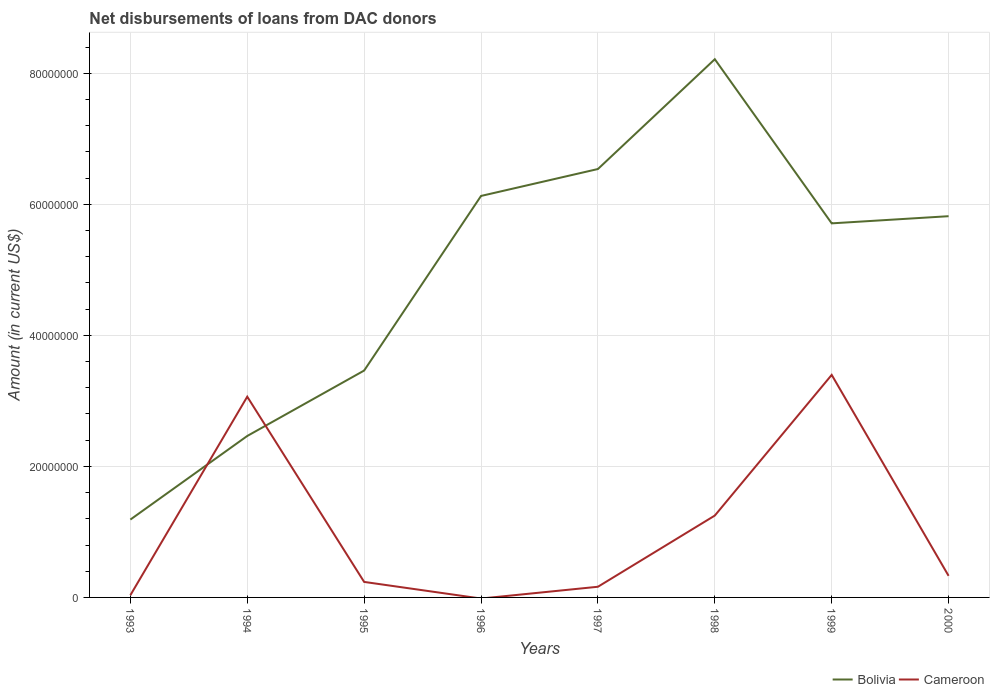How many different coloured lines are there?
Your answer should be compact. 2. Across all years, what is the maximum amount of loans disbursed in Bolivia?
Give a very brief answer. 1.19e+07. What is the total amount of loans disbursed in Bolivia in the graph?
Provide a short and direct response. -4.94e+07. What is the difference between the highest and the second highest amount of loans disbursed in Cameroon?
Provide a short and direct response. 3.40e+07. What is the difference between the highest and the lowest amount of loans disbursed in Cameroon?
Offer a very short reply. 3. Is the amount of loans disbursed in Bolivia strictly greater than the amount of loans disbursed in Cameroon over the years?
Keep it short and to the point. No. Where does the legend appear in the graph?
Ensure brevity in your answer.  Bottom right. What is the title of the graph?
Provide a succinct answer. Net disbursements of loans from DAC donors. Does "Caribbean small states" appear as one of the legend labels in the graph?
Your answer should be very brief. No. What is the label or title of the X-axis?
Make the answer very short. Years. What is the Amount (in current US$) of Bolivia in 1993?
Provide a succinct answer. 1.19e+07. What is the Amount (in current US$) of Cameroon in 1993?
Your response must be concise. 3.40e+05. What is the Amount (in current US$) in Bolivia in 1994?
Provide a succinct answer. 2.46e+07. What is the Amount (in current US$) of Cameroon in 1994?
Provide a succinct answer. 3.06e+07. What is the Amount (in current US$) of Bolivia in 1995?
Ensure brevity in your answer.  3.46e+07. What is the Amount (in current US$) in Cameroon in 1995?
Keep it short and to the point. 2.37e+06. What is the Amount (in current US$) of Bolivia in 1996?
Give a very brief answer. 6.13e+07. What is the Amount (in current US$) in Cameroon in 1996?
Offer a very short reply. 0. What is the Amount (in current US$) in Bolivia in 1997?
Make the answer very short. 6.54e+07. What is the Amount (in current US$) of Cameroon in 1997?
Your answer should be very brief. 1.63e+06. What is the Amount (in current US$) of Bolivia in 1998?
Provide a succinct answer. 8.21e+07. What is the Amount (in current US$) in Cameroon in 1998?
Give a very brief answer. 1.25e+07. What is the Amount (in current US$) of Bolivia in 1999?
Offer a terse response. 5.71e+07. What is the Amount (in current US$) in Cameroon in 1999?
Provide a short and direct response. 3.40e+07. What is the Amount (in current US$) in Bolivia in 2000?
Your answer should be very brief. 5.82e+07. What is the Amount (in current US$) in Cameroon in 2000?
Offer a terse response. 3.30e+06. Across all years, what is the maximum Amount (in current US$) of Bolivia?
Make the answer very short. 8.21e+07. Across all years, what is the maximum Amount (in current US$) of Cameroon?
Keep it short and to the point. 3.40e+07. Across all years, what is the minimum Amount (in current US$) of Bolivia?
Give a very brief answer. 1.19e+07. What is the total Amount (in current US$) in Bolivia in the graph?
Ensure brevity in your answer.  3.95e+08. What is the total Amount (in current US$) of Cameroon in the graph?
Your answer should be very brief. 8.47e+07. What is the difference between the Amount (in current US$) of Bolivia in 1993 and that in 1994?
Ensure brevity in your answer.  -1.28e+07. What is the difference between the Amount (in current US$) in Cameroon in 1993 and that in 1994?
Provide a succinct answer. -3.03e+07. What is the difference between the Amount (in current US$) in Bolivia in 1993 and that in 1995?
Ensure brevity in your answer.  -2.27e+07. What is the difference between the Amount (in current US$) in Cameroon in 1993 and that in 1995?
Ensure brevity in your answer.  -2.03e+06. What is the difference between the Amount (in current US$) of Bolivia in 1993 and that in 1996?
Offer a terse response. -4.94e+07. What is the difference between the Amount (in current US$) of Bolivia in 1993 and that in 1997?
Offer a very short reply. -5.35e+07. What is the difference between the Amount (in current US$) of Cameroon in 1993 and that in 1997?
Give a very brief answer. -1.29e+06. What is the difference between the Amount (in current US$) in Bolivia in 1993 and that in 1998?
Ensure brevity in your answer.  -7.03e+07. What is the difference between the Amount (in current US$) in Cameroon in 1993 and that in 1998?
Ensure brevity in your answer.  -1.22e+07. What is the difference between the Amount (in current US$) in Bolivia in 1993 and that in 1999?
Your answer should be very brief. -4.52e+07. What is the difference between the Amount (in current US$) of Cameroon in 1993 and that in 1999?
Your answer should be compact. -3.36e+07. What is the difference between the Amount (in current US$) in Bolivia in 1993 and that in 2000?
Your response must be concise. -4.63e+07. What is the difference between the Amount (in current US$) in Cameroon in 1993 and that in 2000?
Offer a very short reply. -2.96e+06. What is the difference between the Amount (in current US$) in Bolivia in 1994 and that in 1995?
Provide a short and direct response. -9.98e+06. What is the difference between the Amount (in current US$) of Cameroon in 1994 and that in 1995?
Offer a very short reply. 2.83e+07. What is the difference between the Amount (in current US$) in Bolivia in 1994 and that in 1996?
Give a very brief answer. -3.66e+07. What is the difference between the Amount (in current US$) in Bolivia in 1994 and that in 1997?
Your answer should be very brief. -4.07e+07. What is the difference between the Amount (in current US$) in Cameroon in 1994 and that in 1997?
Make the answer very short. 2.90e+07. What is the difference between the Amount (in current US$) in Bolivia in 1994 and that in 1998?
Your response must be concise. -5.75e+07. What is the difference between the Amount (in current US$) of Cameroon in 1994 and that in 1998?
Offer a terse response. 1.81e+07. What is the difference between the Amount (in current US$) in Bolivia in 1994 and that in 1999?
Provide a short and direct response. -3.25e+07. What is the difference between the Amount (in current US$) in Cameroon in 1994 and that in 1999?
Make the answer very short. -3.33e+06. What is the difference between the Amount (in current US$) in Bolivia in 1994 and that in 2000?
Ensure brevity in your answer.  -3.35e+07. What is the difference between the Amount (in current US$) in Cameroon in 1994 and that in 2000?
Offer a terse response. 2.73e+07. What is the difference between the Amount (in current US$) in Bolivia in 1995 and that in 1996?
Give a very brief answer. -2.66e+07. What is the difference between the Amount (in current US$) of Bolivia in 1995 and that in 1997?
Ensure brevity in your answer.  -3.08e+07. What is the difference between the Amount (in current US$) of Cameroon in 1995 and that in 1997?
Keep it short and to the point. 7.40e+05. What is the difference between the Amount (in current US$) of Bolivia in 1995 and that in 1998?
Offer a very short reply. -4.75e+07. What is the difference between the Amount (in current US$) in Cameroon in 1995 and that in 1998?
Give a very brief answer. -1.01e+07. What is the difference between the Amount (in current US$) of Bolivia in 1995 and that in 1999?
Your answer should be compact. -2.25e+07. What is the difference between the Amount (in current US$) of Cameroon in 1995 and that in 1999?
Your answer should be compact. -3.16e+07. What is the difference between the Amount (in current US$) in Bolivia in 1995 and that in 2000?
Provide a succinct answer. -2.36e+07. What is the difference between the Amount (in current US$) in Cameroon in 1995 and that in 2000?
Offer a very short reply. -9.28e+05. What is the difference between the Amount (in current US$) in Bolivia in 1996 and that in 1997?
Your answer should be compact. -4.11e+06. What is the difference between the Amount (in current US$) in Bolivia in 1996 and that in 1998?
Your response must be concise. -2.09e+07. What is the difference between the Amount (in current US$) of Bolivia in 1996 and that in 1999?
Offer a terse response. 4.18e+06. What is the difference between the Amount (in current US$) of Bolivia in 1996 and that in 2000?
Ensure brevity in your answer.  3.09e+06. What is the difference between the Amount (in current US$) of Bolivia in 1997 and that in 1998?
Offer a very short reply. -1.68e+07. What is the difference between the Amount (in current US$) of Cameroon in 1997 and that in 1998?
Give a very brief answer. -1.09e+07. What is the difference between the Amount (in current US$) in Bolivia in 1997 and that in 1999?
Your answer should be very brief. 8.29e+06. What is the difference between the Amount (in current US$) of Cameroon in 1997 and that in 1999?
Make the answer very short. -3.23e+07. What is the difference between the Amount (in current US$) of Bolivia in 1997 and that in 2000?
Give a very brief answer. 7.20e+06. What is the difference between the Amount (in current US$) of Cameroon in 1997 and that in 2000?
Ensure brevity in your answer.  -1.67e+06. What is the difference between the Amount (in current US$) of Bolivia in 1998 and that in 1999?
Provide a succinct answer. 2.51e+07. What is the difference between the Amount (in current US$) in Cameroon in 1998 and that in 1999?
Keep it short and to the point. -2.15e+07. What is the difference between the Amount (in current US$) in Bolivia in 1998 and that in 2000?
Your response must be concise. 2.40e+07. What is the difference between the Amount (in current US$) in Cameroon in 1998 and that in 2000?
Make the answer very short. 9.20e+06. What is the difference between the Amount (in current US$) in Bolivia in 1999 and that in 2000?
Offer a terse response. -1.09e+06. What is the difference between the Amount (in current US$) in Cameroon in 1999 and that in 2000?
Provide a succinct answer. 3.07e+07. What is the difference between the Amount (in current US$) in Bolivia in 1993 and the Amount (in current US$) in Cameroon in 1994?
Offer a terse response. -1.88e+07. What is the difference between the Amount (in current US$) of Bolivia in 1993 and the Amount (in current US$) of Cameroon in 1995?
Ensure brevity in your answer.  9.52e+06. What is the difference between the Amount (in current US$) in Bolivia in 1993 and the Amount (in current US$) in Cameroon in 1997?
Offer a very short reply. 1.03e+07. What is the difference between the Amount (in current US$) of Bolivia in 1993 and the Amount (in current US$) of Cameroon in 1998?
Offer a terse response. -6.12e+05. What is the difference between the Amount (in current US$) of Bolivia in 1993 and the Amount (in current US$) of Cameroon in 1999?
Your answer should be very brief. -2.21e+07. What is the difference between the Amount (in current US$) of Bolivia in 1993 and the Amount (in current US$) of Cameroon in 2000?
Ensure brevity in your answer.  8.59e+06. What is the difference between the Amount (in current US$) in Bolivia in 1994 and the Amount (in current US$) in Cameroon in 1995?
Your answer should be very brief. 2.23e+07. What is the difference between the Amount (in current US$) in Bolivia in 1994 and the Amount (in current US$) in Cameroon in 1997?
Provide a succinct answer. 2.30e+07. What is the difference between the Amount (in current US$) of Bolivia in 1994 and the Amount (in current US$) of Cameroon in 1998?
Your response must be concise. 1.21e+07. What is the difference between the Amount (in current US$) of Bolivia in 1994 and the Amount (in current US$) of Cameroon in 1999?
Give a very brief answer. -9.32e+06. What is the difference between the Amount (in current US$) in Bolivia in 1994 and the Amount (in current US$) in Cameroon in 2000?
Offer a terse response. 2.13e+07. What is the difference between the Amount (in current US$) of Bolivia in 1995 and the Amount (in current US$) of Cameroon in 1997?
Your response must be concise. 3.30e+07. What is the difference between the Amount (in current US$) in Bolivia in 1995 and the Amount (in current US$) in Cameroon in 1998?
Make the answer very short. 2.21e+07. What is the difference between the Amount (in current US$) of Bolivia in 1995 and the Amount (in current US$) of Cameroon in 1999?
Make the answer very short. 6.61e+05. What is the difference between the Amount (in current US$) of Bolivia in 1995 and the Amount (in current US$) of Cameroon in 2000?
Your answer should be compact. 3.13e+07. What is the difference between the Amount (in current US$) in Bolivia in 1996 and the Amount (in current US$) in Cameroon in 1997?
Offer a very short reply. 5.97e+07. What is the difference between the Amount (in current US$) in Bolivia in 1996 and the Amount (in current US$) in Cameroon in 1998?
Keep it short and to the point. 4.88e+07. What is the difference between the Amount (in current US$) in Bolivia in 1996 and the Amount (in current US$) in Cameroon in 1999?
Ensure brevity in your answer.  2.73e+07. What is the difference between the Amount (in current US$) of Bolivia in 1996 and the Amount (in current US$) of Cameroon in 2000?
Your answer should be very brief. 5.80e+07. What is the difference between the Amount (in current US$) of Bolivia in 1997 and the Amount (in current US$) of Cameroon in 1998?
Offer a terse response. 5.29e+07. What is the difference between the Amount (in current US$) of Bolivia in 1997 and the Amount (in current US$) of Cameroon in 1999?
Make the answer very short. 3.14e+07. What is the difference between the Amount (in current US$) in Bolivia in 1997 and the Amount (in current US$) in Cameroon in 2000?
Provide a succinct answer. 6.21e+07. What is the difference between the Amount (in current US$) of Bolivia in 1998 and the Amount (in current US$) of Cameroon in 1999?
Keep it short and to the point. 4.82e+07. What is the difference between the Amount (in current US$) in Bolivia in 1998 and the Amount (in current US$) in Cameroon in 2000?
Ensure brevity in your answer.  7.89e+07. What is the difference between the Amount (in current US$) of Bolivia in 1999 and the Amount (in current US$) of Cameroon in 2000?
Make the answer very short. 5.38e+07. What is the average Amount (in current US$) of Bolivia per year?
Give a very brief answer. 4.94e+07. What is the average Amount (in current US$) in Cameroon per year?
Your answer should be compact. 1.06e+07. In the year 1993, what is the difference between the Amount (in current US$) of Bolivia and Amount (in current US$) of Cameroon?
Your answer should be compact. 1.15e+07. In the year 1994, what is the difference between the Amount (in current US$) of Bolivia and Amount (in current US$) of Cameroon?
Keep it short and to the point. -6.00e+06. In the year 1995, what is the difference between the Amount (in current US$) in Bolivia and Amount (in current US$) in Cameroon?
Give a very brief answer. 3.23e+07. In the year 1997, what is the difference between the Amount (in current US$) of Bolivia and Amount (in current US$) of Cameroon?
Give a very brief answer. 6.38e+07. In the year 1998, what is the difference between the Amount (in current US$) of Bolivia and Amount (in current US$) of Cameroon?
Your answer should be very brief. 6.97e+07. In the year 1999, what is the difference between the Amount (in current US$) in Bolivia and Amount (in current US$) in Cameroon?
Your answer should be very brief. 2.31e+07. In the year 2000, what is the difference between the Amount (in current US$) in Bolivia and Amount (in current US$) in Cameroon?
Keep it short and to the point. 5.49e+07. What is the ratio of the Amount (in current US$) of Bolivia in 1993 to that in 1994?
Keep it short and to the point. 0.48. What is the ratio of the Amount (in current US$) of Cameroon in 1993 to that in 1994?
Your response must be concise. 0.01. What is the ratio of the Amount (in current US$) in Bolivia in 1993 to that in 1995?
Your response must be concise. 0.34. What is the ratio of the Amount (in current US$) in Cameroon in 1993 to that in 1995?
Ensure brevity in your answer.  0.14. What is the ratio of the Amount (in current US$) in Bolivia in 1993 to that in 1996?
Give a very brief answer. 0.19. What is the ratio of the Amount (in current US$) in Bolivia in 1993 to that in 1997?
Provide a succinct answer. 0.18. What is the ratio of the Amount (in current US$) in Cameroon in 1993 to that in 1997?
Your answer should be compact. 0.21. What is the ratio of the Amount (in current US$) of Bolivia in 1993 to that in 1998?
Your answer should be very brief. 0.14. What is the ratio of the Amount (in current US$) in Cameroon in 1993 to that in 1998?
Make the answer very short. 0.03. What is the ratio of the Amount (in current US$) in Bolivia in 1993 to that in 1999?
Offer a very short reply. 0.21. What is the ratio of the Amount (in current US$) of Cameroon in 1993 to that in 1999?
Provide a succinct answer. 0.01. What is the ratio of the Amount (in current US$) of Bolivia in 1993 to that in 2000?
Make the answer very short. 0.2. What is the ratio of the Amount (in current US$) in Cameroon in 1993 to that in 2000?
Keep it short and to the point. 0.1. What is the ratio of the Amount (in current US$) in Bolivia in 1994 to that in 1995?
Give a very brief answer. 0.71. What is the ratio of the Amount (in current US$) of Cameroon in 1994 to that in 1995?
Provide a short and direct response. 12.94. What is the ratio of the Amount (in current US$) in Bolivia in 1994 to that in 1996?
Keep it short and to the point. 0.4. What is the ratio of the Amount (in current US$) in Bolivia in 1994 to that in 1997?
Offer a terse response. 0.38. What is the ratio of the Amount (in current US$) of Cameroon in 1994 to that in 1997?
Your response must be concise. 18.82. What is the ratio of the Amount (in current US$) in Cameroon in 1994 to that in 1998?
Make the answer very short. 2.45. What is the ratio of the Amount (in current US$) in Bolivia in 1994 to that in 1999?
Keep it short and to the point. 0.43. What is the ratio of the Amount (in current US$) in Cameroon in 1994 to that in 1999?
Provide a succinct answer. 0.9. What is the ratio of the Amount (in current US$) of Bolivia in 1994 to that in 2000?
Your answer should be compact. 0.42. What is the ratio of the Amount (in current US$) in Cameroon in 1994 to that in 2000?
Your answer should be compact. 9.3. What is the ratio of the Amount (in current US$) in Bolivia in 1995 to that in 1996?
Give a very brief answer. 0.57. What is the ratio of the Amount (in current US$) in Bolivia in 1995 to that in 1997?
Your answer should be very brief. 0.53. What is the ratio of the Amount (in current US$) in Cameroon in 1995 to that in 1997?
Provide a short and direct response. 1.45. What is the ratio of the Amount (in current US$) of Bolivia in 1995 to that in 1998?
Make the answer very short. 0.42. What is the ratio of the Amount (in current US$) in Cameroon in 1995 to that in 1998?
Provide a short and direct response. 0.19. What is the ratio of the Amount (in current US$) in Bolivia in 1995 to that in 1999?
Make the answer very short. 0.61. What is the ratio of the Amount (in current US$) of Cameroon in 1995 to that in 1999?
Provide a succinct answer. 0.07. What is the ratio of the Amount (in current US$) of Bolivia in 1995 to that in 2000?
Keep it short and to the point. 0.6. What is the ratio of the Amount (in current US$) in Cameroon in 1995 to that in 2000?
Offer a very short reply. 0.72. What is the ratio of the Amount (in current US$) of Bolivia in 1996 to that in 1997?
Your answer should be very brief. 0.94. What is the ratio of the Amount (in current US$) in Bolivia in 1996 to that in 1998?
Your response must be concise. 0.75. What is the ratio of the Amount (in current US$) in Bolivia in 1996 to that in 1999?
Provide a short and direct response. 1.07. What is the ratio of the Amount (in current US$) in Bolivia in 1996 to that in 2000?
Your answer should be compact. 1.05. What is the ratio of the Amount (in current US$) in Bolivia in 1997 to that in 1998?
Your answer should be very brief. 0.8. What is the ratio of the Amount (in current US$) in Cameroon in 1997 to that in 1998?
Offer a terse response. 0.13. What is the ratio of the Amount (in current US$) in Bolivia in 1997 to that in 1999?
Your answer should be compact. 1.15. What is the ratio of the Amount (in current US$) in Cameroon in 1997 to that in 1999?
Provide a succinct answer. 0.05. What is the ratio of the Amount (in current US$) of Bolivia in 1997 to that in 2000?
Keep it short and to the point. 1.12. What is the ratio of the Amount (in current US$) in Cameroon in 1997 to that in 2000?
Provide a short and direct response. 0.49. What is the ratio of the Amount (in current US$) of Bolivia in 1998 to that in 1999?
Ensure brevity in your answer.  1.44. What is the ratio of the Amount (in current US$) in Cameroon in 1998 to that in 1999?
Provide a succinct answer. 0.37. What is the ratio of the Amount (in current US$) in Bolivia in 1998 to that in 2000?
Your answer should be compact. 1.41. What is the ratio of the Amount (in current US$) in Cameroon in 1998 to that in 2000?
Your answer should be compact. 3.79. What is the ratio of the Amount (in current US$) of Bolivia in 1999 to that in 2000?
Give a very brief answer. 0.98. What is the ratio of the Amount (in current US$) in Cameroon in 1999 to that in 2000?
Offer a very short reply. 10.31. What is the difference between the highest and the second highest Amount (in current US$) of Bolivia?
Provide a short and direct response. 1.68e+07. What is the difference between the highest and the second highest Amount (in current US$) of Cameroon?
Your answer should be very brief. 3.33e+06. What is the difference between the highest and the lowest Amount (in current US$) of Bolivia?
Offer a very short reply. 7.03e+07. What is the difference between the highest and the lowest Amount (in current US$) of Cameroon?
Keep it short and to the point. 3.40e+07. 